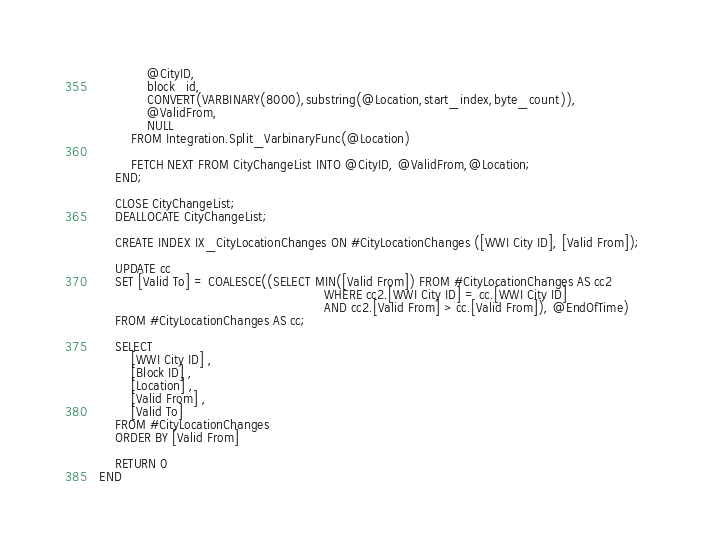<code> <loc_0><loc_0><loc_500><loc_500><_SQL_>			@CityID,
			block_id,
			CONVERT(VARBINARY(8000),substring(@Location,start_index,byte_count)),
			@ValidFrom,
			NULL
		FROM Integration.Split_VarbinaryFunc(@Location)

        FETCH NEXT FROM CityChangeList INTO @CityID, @ValidFrom,@Location;
    END;

    CLOSE CityChangeList;
    DEALLOCATE CityChangeList;

	CREATE INDEX IX_CityLocationChanges ON #CityLocationChanges ([WWI City ID], [Valid From]);

	UPDATE cc
    SET [Valid To] = COALESCE((SELECT MIN([Valid From]) FROM #CityLocationChanges AS cc2
                                                        WHERE cc2.[WWI City ID] = cc.[WWI City ID]
                                                        AND cc2.[Valid From] > cc.[Valid From]), @EndOfTime)
    FROM #CityLocationChanges AS cc;

	SELECT
		[WWI City ID] ,
		[Block ID] ,
		[Location] ,
		[Valid From] ,
		[Valid To]
	FROM #CityLocationChanges
	ORDER BY [Valid From]

	RETURN 0
END
</code> 